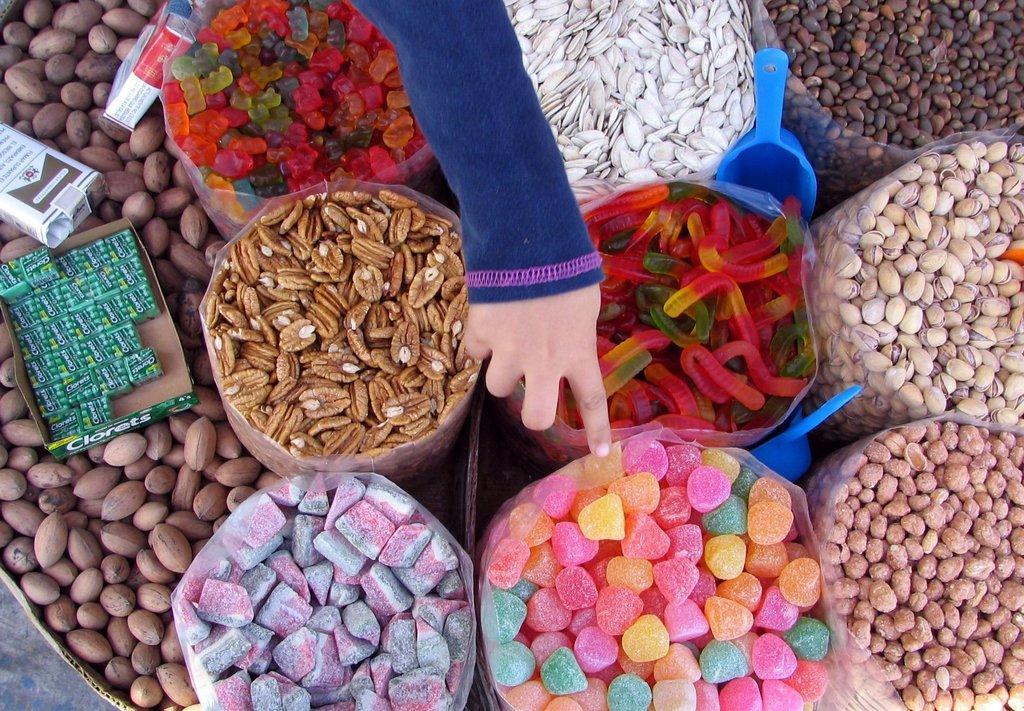Describe this image in one or two sentences. In the picture I can see things in a plastic bag. I can also see blue color objects, boxes, a person's hand and some other things. 